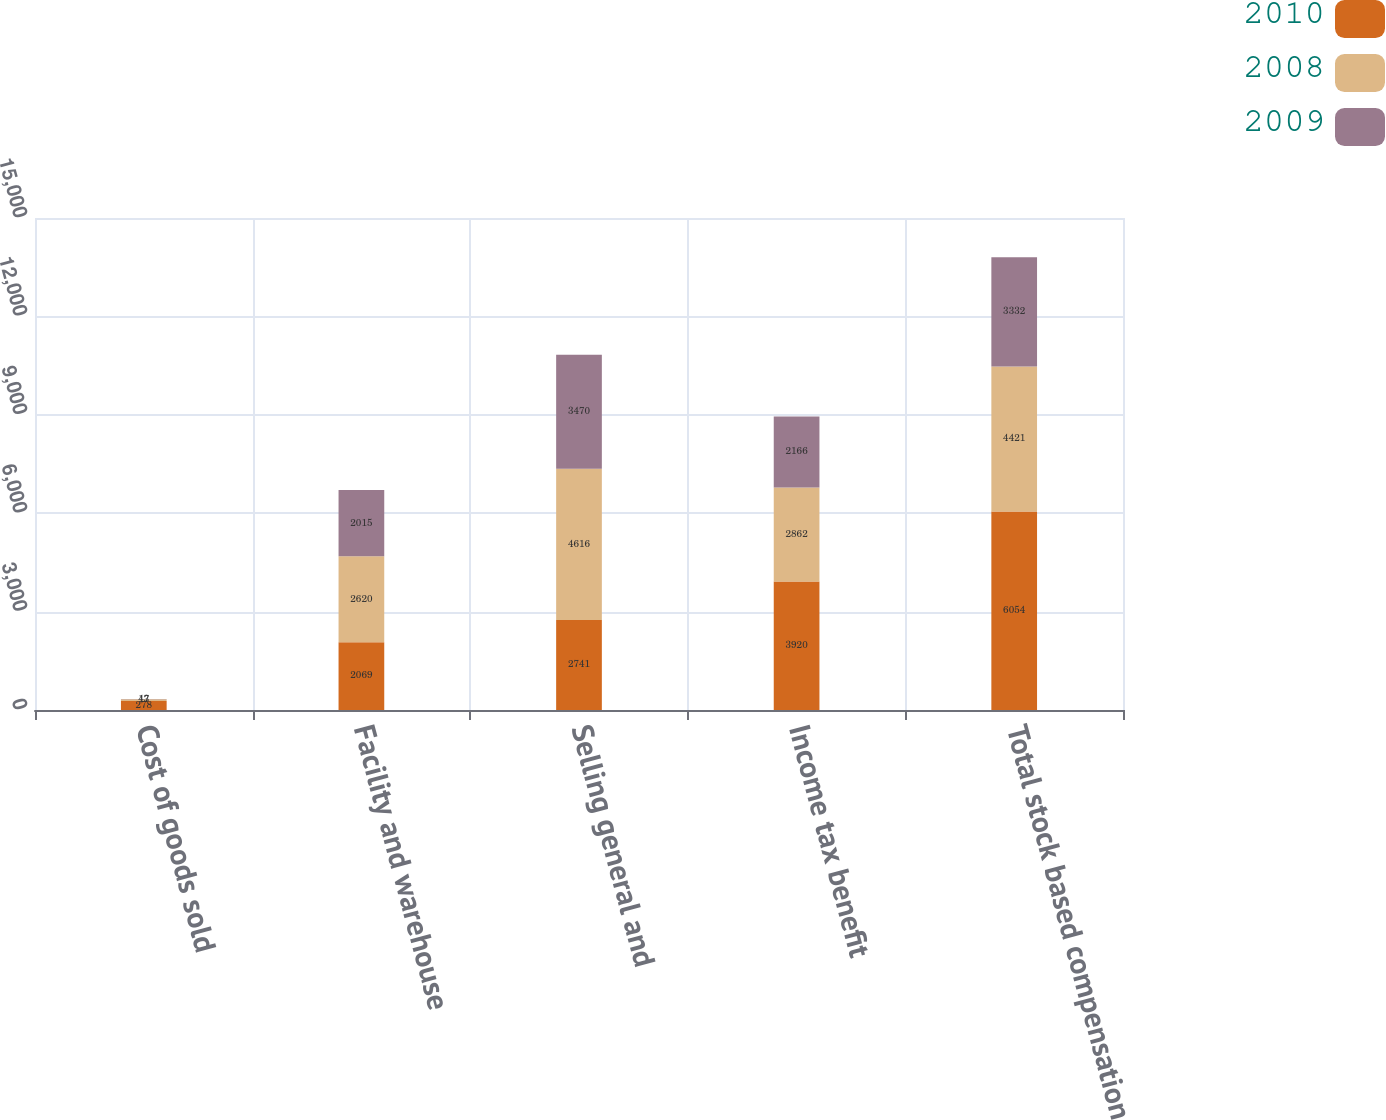Convert chart. <chart><loc_0><loc_0><loc_500><loc_500><stacked_bar_chart><ecel><fcel>Cost of goods sold<fcel>Facility and warehouse<fcel>Selling general and<fcel>Income tax benefit<fcel>Total stock based compensation<nl><fcel>2010<fcel>278<fcel>2069<fcel>2741<fcel>3920<fcel>6054<nl><fcel>2008<fcel>47<fcel>2620<fcel>4616<fcel>2862<fcel>4421<nl><fcel>2009<fcel>13<fcel>2015<fcel>3470<fcel>2166<fcel>3332<nl></chart> 